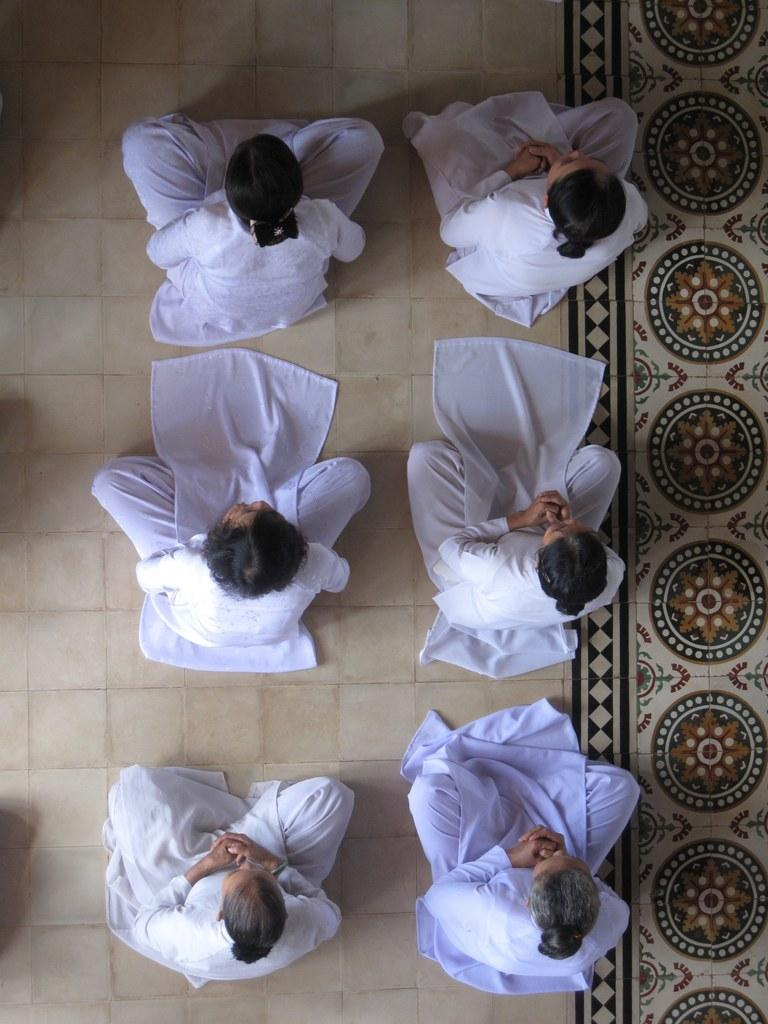How many people are in the image? There are six persons in the image. What are the persons wearing? The persons are wearing white dresses. What position are the persons in? The persons are sitting on the floor. From what angle was the image taken? The image is taken from the top. What type of mask is the person wearing in the image? There are no masks present in the image; the persons are wearing white dresses. What color is the ink used to write on the guitar in the image? There is no guitar present in the image, so there is no ink to consider. 